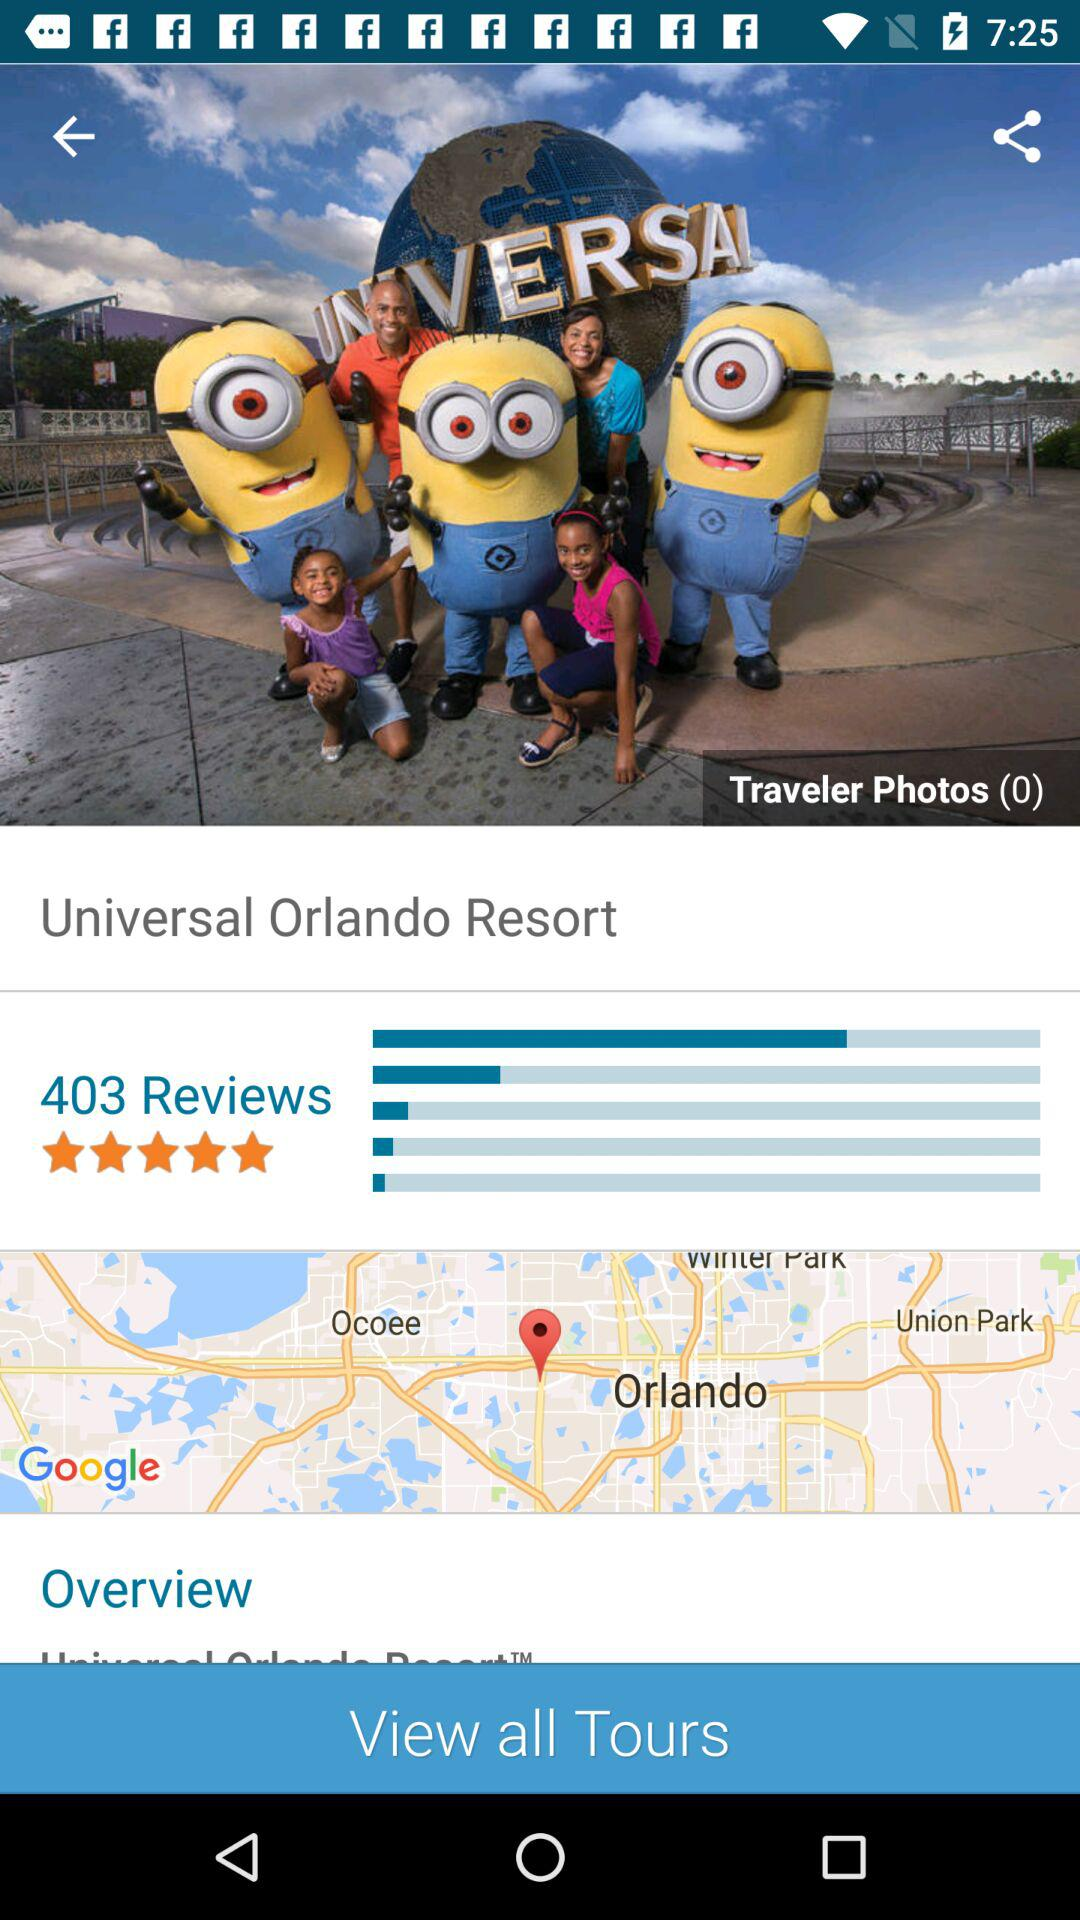How many more reviews does the Universal Orlando Resort have than the number of traveler photos?
Answer the question using a single word or phrase. 403 